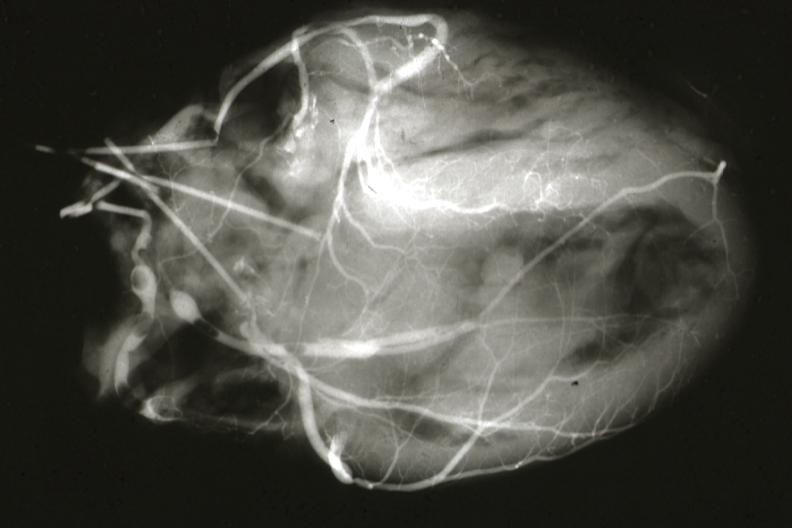s myocardial infarct present?
Answer the question using a single word or phrase. Yes 